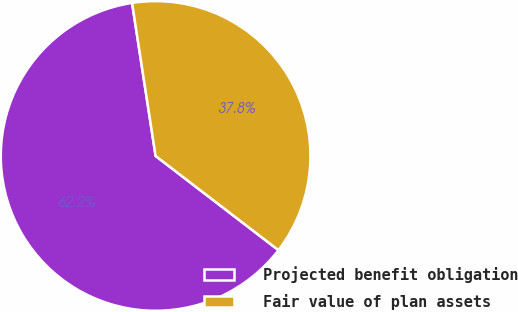Convert chart to OTSL. <chart><loc_0><loc_0><loc_500><loc_500><pie_chart><fcel>Projected benefit obligation<fcel>Fair value of plan assets<nl><fcel>62.16%<fcel>37.84%<nl></chart> 